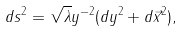<formula> <loc_0><loc_0><loc_500><loc_500>d s ^ { 2 } = \sqrt { \lambda } y ^ { - 2 } ( d y ^ { 2 } + d \vec { x } ^ { 2 } ) ,</formula> 